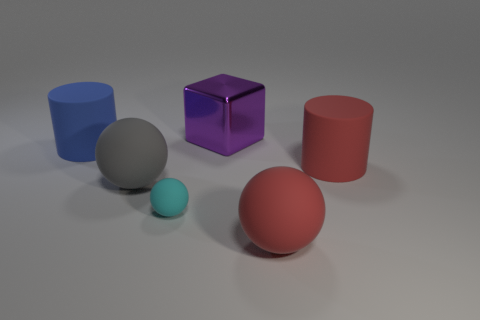What is the shape of the cyan object that is the same material as the red ball?
Your answer should be very brief. Sphere. What material is the large cylinder to the right of the rubber thing behind the cylinder right of the large purple shiny cube?
Offer a very short reply. Rubber. How many cylinders have the same material as the gray ball?
Keep it short and to the point. 2. There is a blue rubber thing that is the same size as the gray rubber thing; what shape is it?
Your response must be concise. Cylinder. Are there any gray spheres in front of the big blue thing?
Give a very brief answer. Yes. Is there another purple thing of the same shape as the small object?
Your answer should be very brief. No. There is a big thing that is behind the blue matte object; is it the same shape as the blue rubber object that is in front of the big purple cube?
Offer a very short reply. No. Is there a yellow rubber ball of the same size as the purple block?
Keep it short and to the point. No. Are there an equal number of big red spheres that are on the left side of the purple shiny thing and red things behind the gray ball?
Your answer should be very brief. No. Are the big cylinder on the right side of the big purple object and the large cylinder to the left of the purple thing made of the same material?
Keep it short and to the point. Yes. 